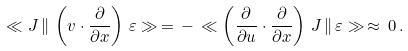Convert formula to latex. <formula><loc_0><loc_0><loc_500><loc_500>\ll J \, \| \, \left ( v \cdot \frac { \partial } { \partial x } \right ) \, \varepsilon \gg \, = \, - \, \ll \left ( \frac { \partial } { \partial u } \cdot \frac { \partial } { \partial x } \right ) \, J \, \| \, \varepsilon \gg \, \approx \, 0 \, .</formula> 